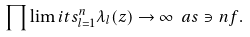Convert formula to latex. <formula><loc_0><loc_0><loc_500><loc_500>\prod \lim i t s _ { l = 1 } ^ { n } \lambda _ { l } ( z ) \rightarrow \infty \ a s \ni n f .</formula> 